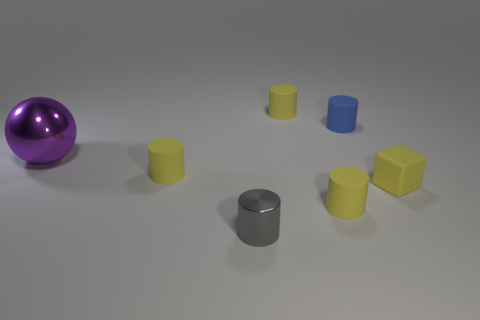How many yellow cylinders must be subtracted to get 1 yellow cylinders? 2 Add 3 yellow rubber blocks. How many objects exist? 10 Subtract all cylinders. How many objects are left? 2 Subtract 1 blocks. How many blocks are left? 0 Subtract all gray cylinders. How many cylinders are left? 4 Subtract all tiny gray cylinders. How many cylinders are left? 4 Subtract 0 green cubes. How many objects are left? 7 Subtract all red cubes. Subtract all purple balls. How many cubes are left? 1 Subtract all gray balls. How many blue cylinders are left? 1 Subtract all small yellow cubes. Subtract all yellow cylinders. How many objects are left? 3 